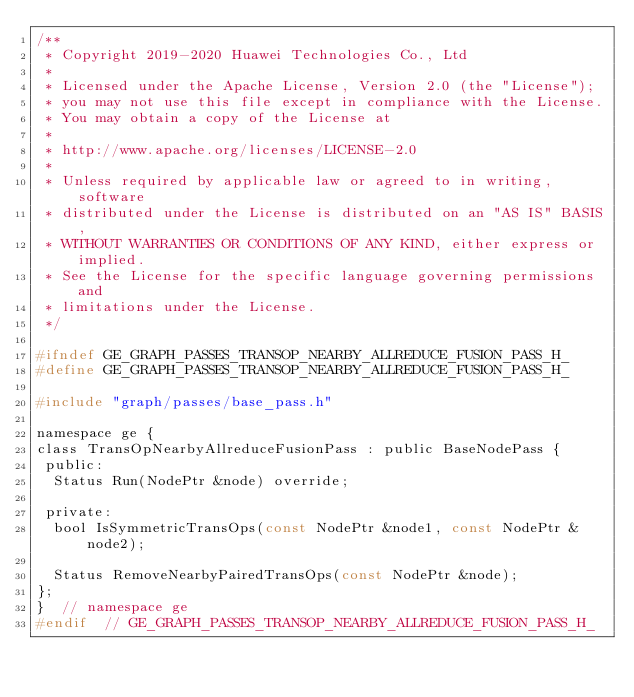<code> <loc_0><loc_0><loc_500><loc_500><_C_>/**
 * Copyright 2019-2020 Huawei Technologies Co., Ltd
 *
 * Licensed under the Apache License, Version 2.0 (the "License");
 * you may not use this file except in compliance with the License.
 * You may obtain a copy of the License at
 *
 * http://www.apache.org/licenses/LICENSE-2.0
 *
 * Unless required by applicable law or agreed to in writing, software
 * distributed under the License is distributed on an "AS IS" BASIS,
 * WITHOUT WARRANTIES OR CONDITIONS OF ANY KIND, either express or implied.
 * See the License for the specific language governing permissions and
 * limitations under the License.
 */

#ifndef GE_GRAPH_PASSES_TRANSOP_NEARBY_ALLREDUCE_FUSION_PASS_H_
#define GE_GRAPH_PASSES_TRANSOP_NEARBY_ALLREDUCE_FUSION_PASS_H_

#include "graph/passes/base_pass.h"

namespace ge {
class TransOpNearbyAllreduceFusionPass : public BaseNodePass {
 public:
  Status Run(NodePtr &node) override;

 private:
  bool IsSymmetricTransOps(const NodePtr &node1, const NodePtr &node2);

  Status RemoveNearbyPairedTransOps(const NodePtr &node);
};
}  // namespace ge
#endif  // GE_GRAPH_PASSES_TRANSOP_NEARBY_ALLREDUCE_FUSION_PASS_H_
</code> 